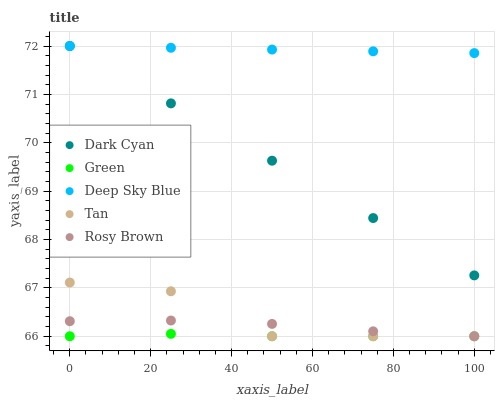Does Green have the minimum area under the curve?
Answer yes or no. Yes. Does Deep Sky Blue have the maximum area under the curve?
Answer yes or no. Yes. Does Tan have the minimum area under the curve?
Answer yes or no. No. Does Tan have the maximum area under the curve?
Answer yes or no. No. Is Deep Sky Blue the smoothest?
Answer yes or no. Yes. Is Tan the roughest?
Answer yes or no. Yes. Is Rosy Brown the smoothest?
Answer yes or no. No. Is Rosy Brown the roughest?
Answer yes or no. No. Does Tan have the lowest value?
Answer yes or no. Yes. Does Deep Sky Blue have the lowest value?
Answer yes or no. No. Does Deep Sky Blue have the highest value?
Answer yes or no. Yes. Does Tan have the highest value?
Answer yes or no. No. Is Tan less than Dark Cyan?
Answer yes or no. Yes. Is Dark Cyan greater than Rosy Brown?
Answer yes or no. Yes. Does Green intersect Rosy Brown?
Answer yes or no. Yes. Is Green less than Rosy Brown?
Answer yes or no. No. Is Green greater than Rosy Brown?
Answer yes or no. No. Does Tan intersect Dark Cyan?
Answer yes or no. No. 